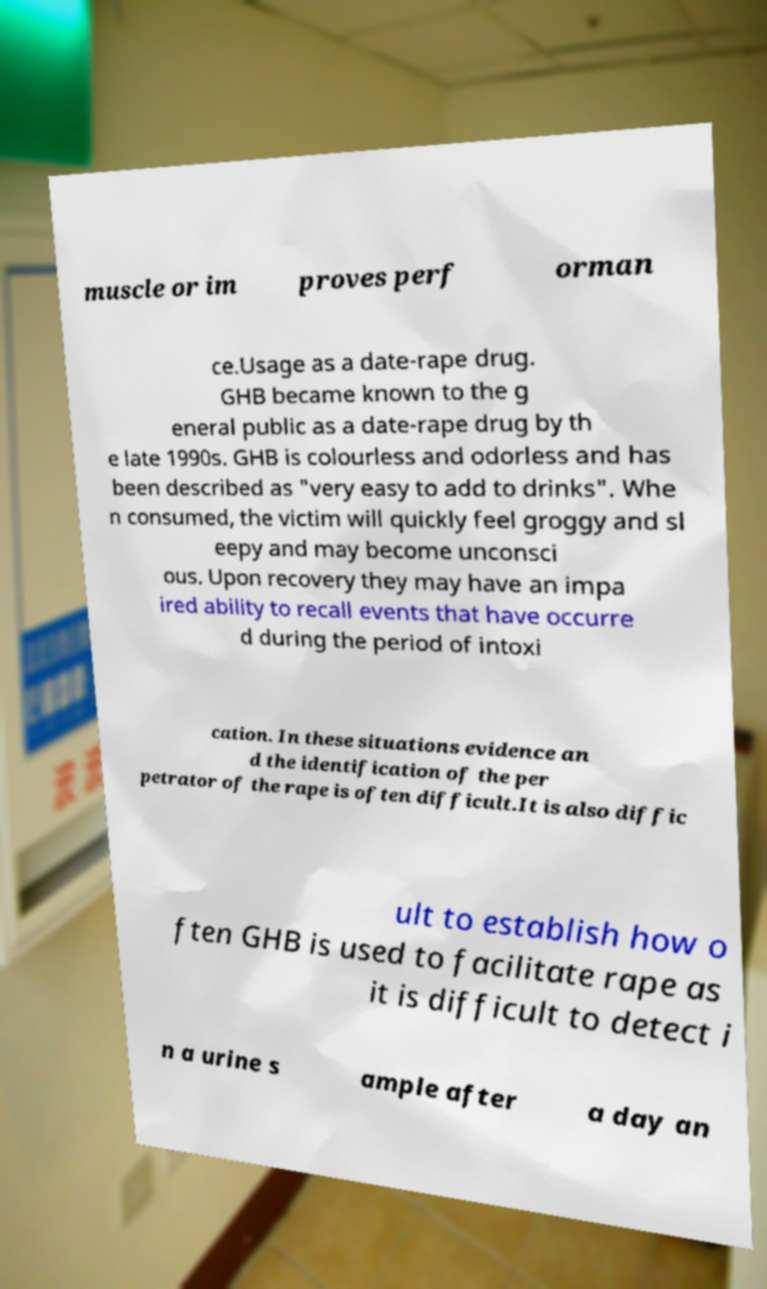Could you assist in decoding the text presented in this image and type it out clearly? muscle or im proves perf orman ce.Usage as a date-rape drug. GHB became known to the g eneral public as a date-rape drug by th e late 1990s. GHB is colourless and odorless and has been described as "very easy to add to drinks". Whe n consumed, the victim will quickly feel groggy and sl eepy and may become unconsci ous. Upon recovery they may have an impa ired ability to recall events that have occurre d during the period of intoxi cation. In these situations evidence an d the identification of the per petrator of the rape is often difficult.It is also diffic ult to establish how o ften GHB is used to facilitate rape as it is difficult to detect i n a urine s ample after a day an 